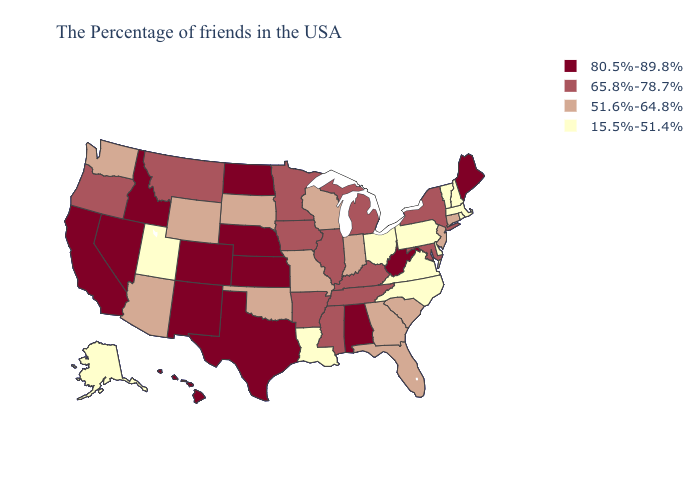What is the value of Louisiana?
Concise answer only. 15.5%-51.4%. Does the first symbol in the legend represent the smallest category?
Write a very short answer. No. Among the states that border Missouri , does Oklahoma have the highest value?
Give a very brief answer. No. What is the highest value in the USA?
Write a very short answer. 80.5%-89.8%. What is the highest value in states that border Maryland?
Keep it brief. 80.5%-89.8%. Is the legend a continuous bar?
Concise answer only. No. Does Vermont have the lowest value in the USA?
Be succinct. Yes. What is the highest value in the USA?
Write a very short answer. 80.5%-89.8%. What is the highest value in the USA?
Concise answer only. 80.5%-89.8%. Name the states that have a value in the range 51.6%-64.8%?
Write a very short answer. Connecticut, New Jersey, South Carolina, Florida, Georgia, Indiana, Wisconsin, Missouri, Oklahoma, South Dakota, Wyoming, Arizona, Washington. Does Iowa have the same value as Wisconsin?
Write a very short answer. No. How many symbols are there in the legend?
Keep it brief. 4. Does Ohio have the lowest value in the MidWest?
Keep it brief. Yes. Does Vermont have the highest value in the Northeast?
Write a very short answer. No. 